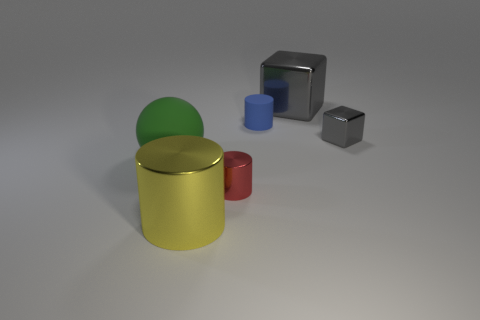There is a matte thing to the right of the large green object; is there a large metallic block on the right side of it?
Provide a succinct answer. Yes. What color is the rubber thing that is the same shape as the yellow metallic thing?
Give a very brief answer. Blue. How many other rubber balls have the same color as the big rubber sphere?
Make the answer very short. 0. The big shiny thing that is behind the object to the right of the gray metal object behind the tiny block is what color?
Ensure brevity in your answer.  Gray. Are the small blue thing and the red object made of the same material?
Your answer should be compact. No. Is the large yellow shiny object the same shape as the big green rubber thing?
Offer a terse response. No. Are there the same number of blue cylinders that are in front of the large green rubber sphere and small gray metallic cubes that are in front of the small block?
Ensure brevity in your answer.  Yes. There is another cylinder that is the same material as the big yellow cylinder; what is its color?
Provide a succinct answer. Red. How many green objects are the same material as the large yellow thing?
Your answer should be very brief. 0. There is a shiny cylinder that is behind the large yellow object; is its color the same as the large sphere?
Ensure brevity in your answer.  No. 